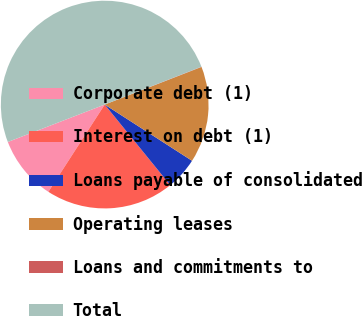Convert chart to OTSL. <chart><loc_0><loc_0><loc_500><loc_500><pie_chart><fcel>Corporate debt (1)<fcel>Interest on debt (1)<fcel>Loans payable of consolidated<fcel>Operating leases<fcel>Loans and commitments to<fcel>Total<nl><fcel>10.01%<fcel>19.99%<fcel>5.03%<fcel>15.0%<fcel>0.04%<fcel>49.93%<nl></chart> 